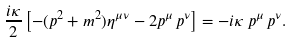<formula> <loc_0><loc_0><loc_500><loc_500>\frac { i \kappa } { 2 } \left [ - ( p ^ { 2 } + m ^ { 2 } ) \eta ^ { \mu \nu } - 2 p ^ { \mu } \, p ^ { \nu } \right ] = - i \kappa \, p ^ { \mu } \, p ^ { \nu } .</formula> 